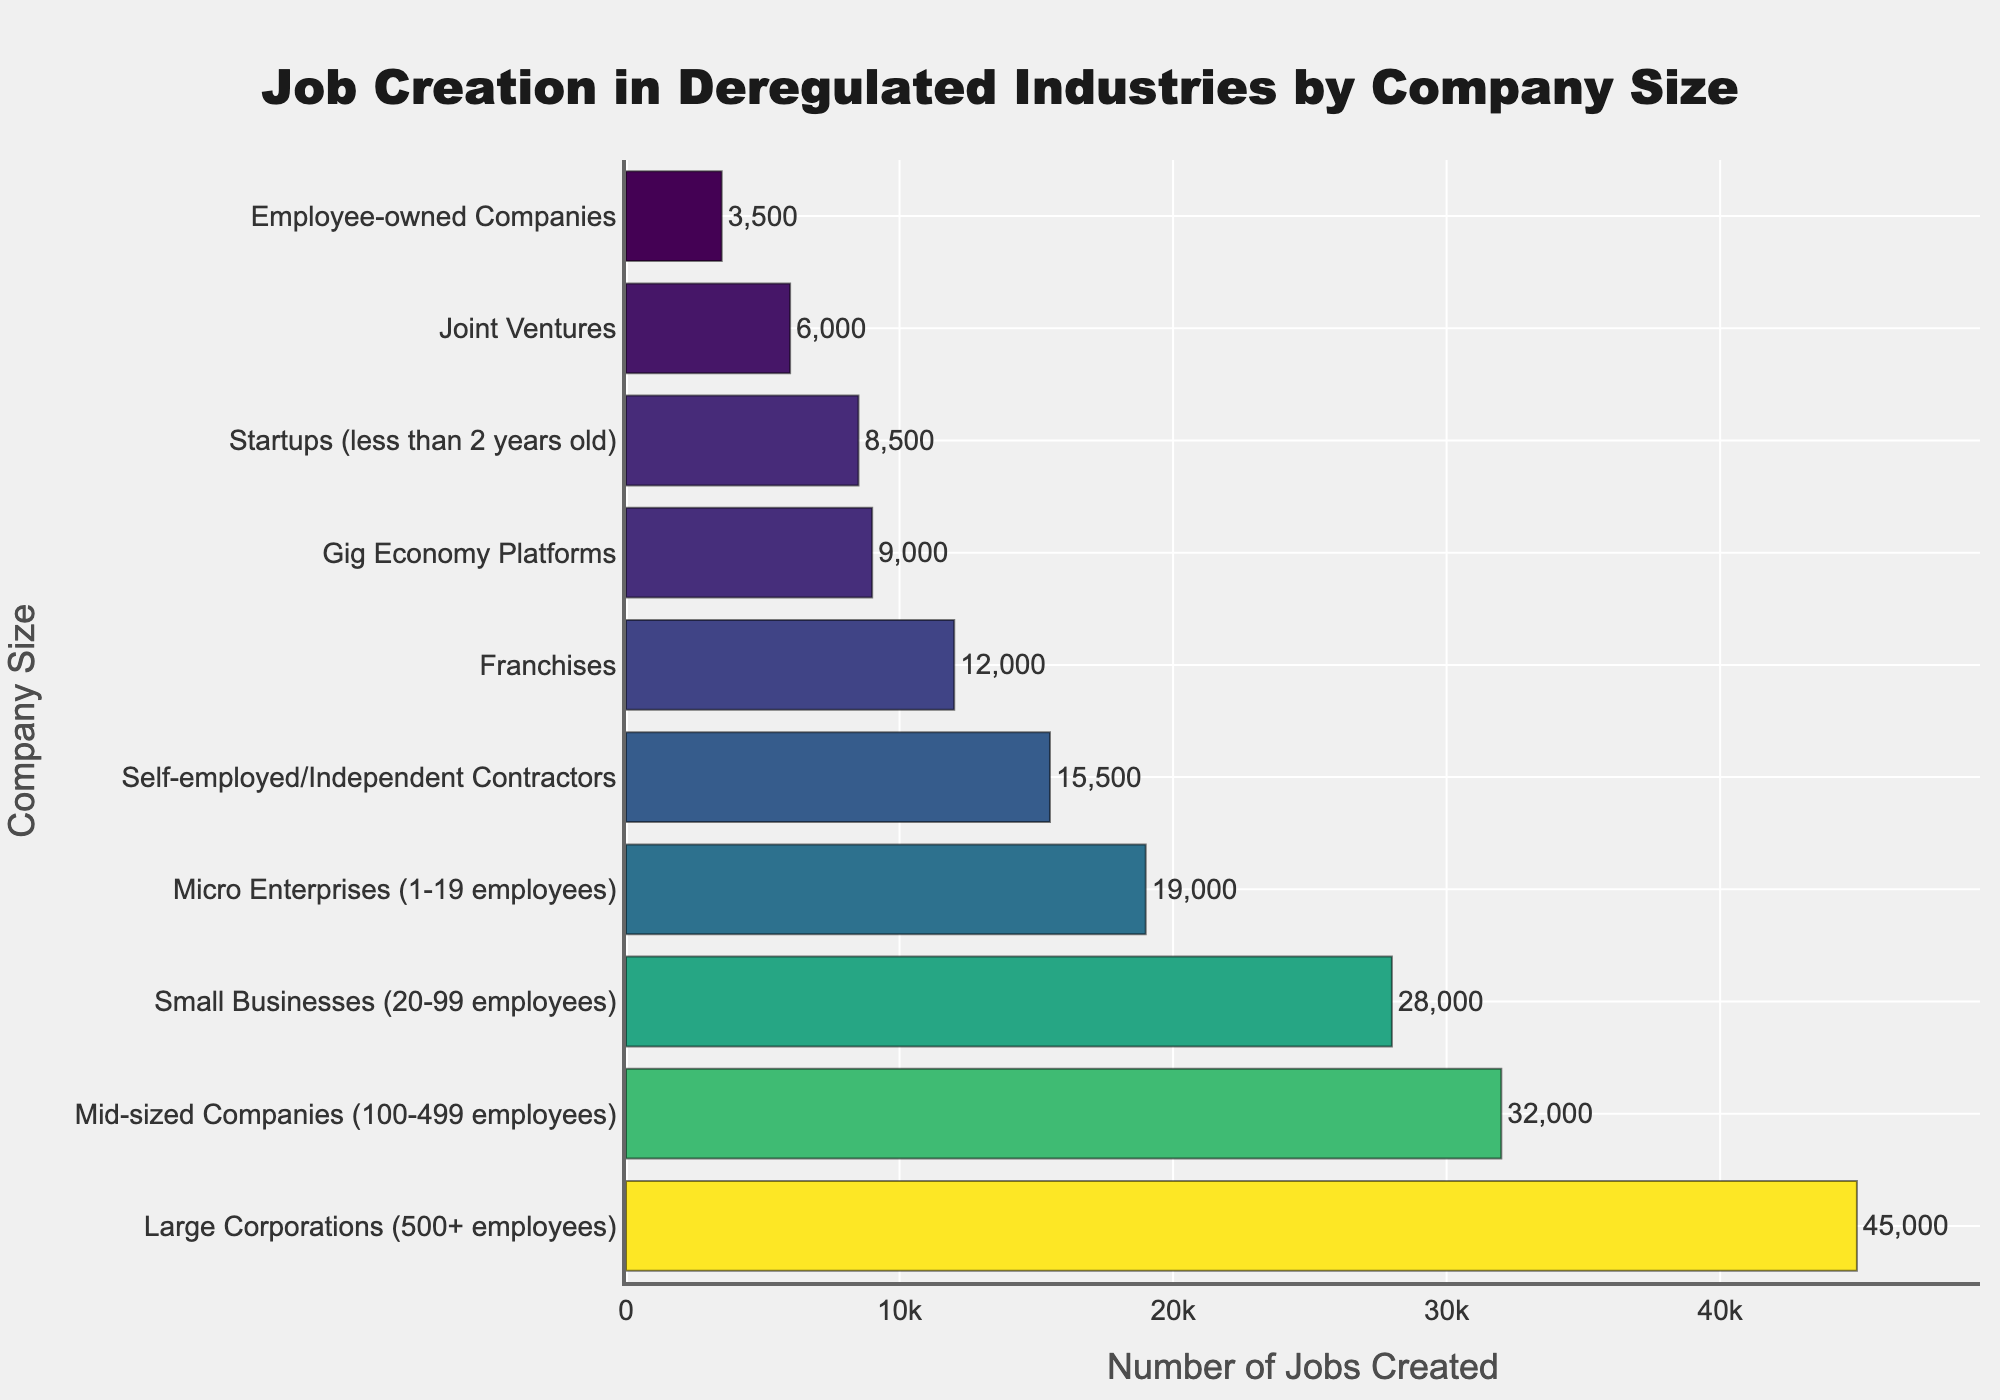What's the total number of jobs created by Large Corporations and Mid-sized Companies combined? Sum the jobs created by Large Corporations (45000) and Mid-sized Companies (32000). 45000 + 32000 = 77000
Answer: 77000 Which company size created the least number of jobs? Scan the bar lengths to identify the shortest bar. Employee-owned Companies created the least number of jobs at 3500.
Answer: Employee-owned Companies How much more jobs did Large Corporations create compared to Startups? Subtract the jobs created by Startups (8500) from the jobs created by Large Corporations (45000). 45000 - 8500 = 36500
Answer: 36500 What is the average number of jobs created by all the company sizes listed? Sum all the job creation figures and divide by the number of company sizes. (45000 + 32000 + 28000 + 19000 + 8500 + 12000 + 15500 + 9000 + 6000 + 3500) / 10 = 179500 / 10 = 17950
Answer: 17950 How many more jobs did Small Businesses create than Self-employed/Independent Contractors? Subtract the jobs created by Self-employed/Independent Contractors (15500) from those created by Small Businesses (28000). 28000 - 15500 = 12500
Answer: 12500 Are there any company sizes that created an equal or similar number of jobs? Compare the job creation numbers for closeness. Mid-sized Companies (32000) and Small Businesses (28000) have somewhat closer figures, but they are not equal.
Answer: None How does the number of jobs created by Gig Economy Platforms compare to those created by Franchises? Identify the heights of the bars for Gig Economy Platforms and Franchises. Gig Economy Platforms created 9000 jobs, and Franchises created 12000 jobs. 12000 is more than 9000.
Answer: Franchises created more jobs What is the combined contribution of Micro Enterprises and Startups to job creation? Add the jobs created by Micro Enterprises (19000) and Startups (8500). 19000 + 8500 = 27500
Answer: 27500 What's the difference in job creation between the top contributor and the second top contributor? Subtract the jobs created by Mid-sized Companies (32000), the second top contributor, from those created by Large Corporations (45000), the top contributor. 45000 - 32000 = 13000
Answer: 13000 